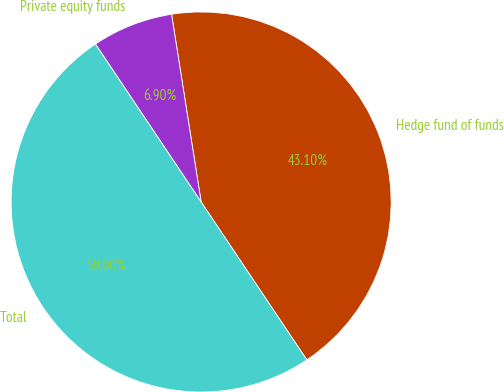<chart> <loc_0><loc_0><loc_500><loc_500><pie_chart><fcel>Hedge fund of funds<fcel>Private equity funds<fcel>Total<nl><fcel>43.1%<fcel>6.9%<fcel>50.0%<nl></chart> 